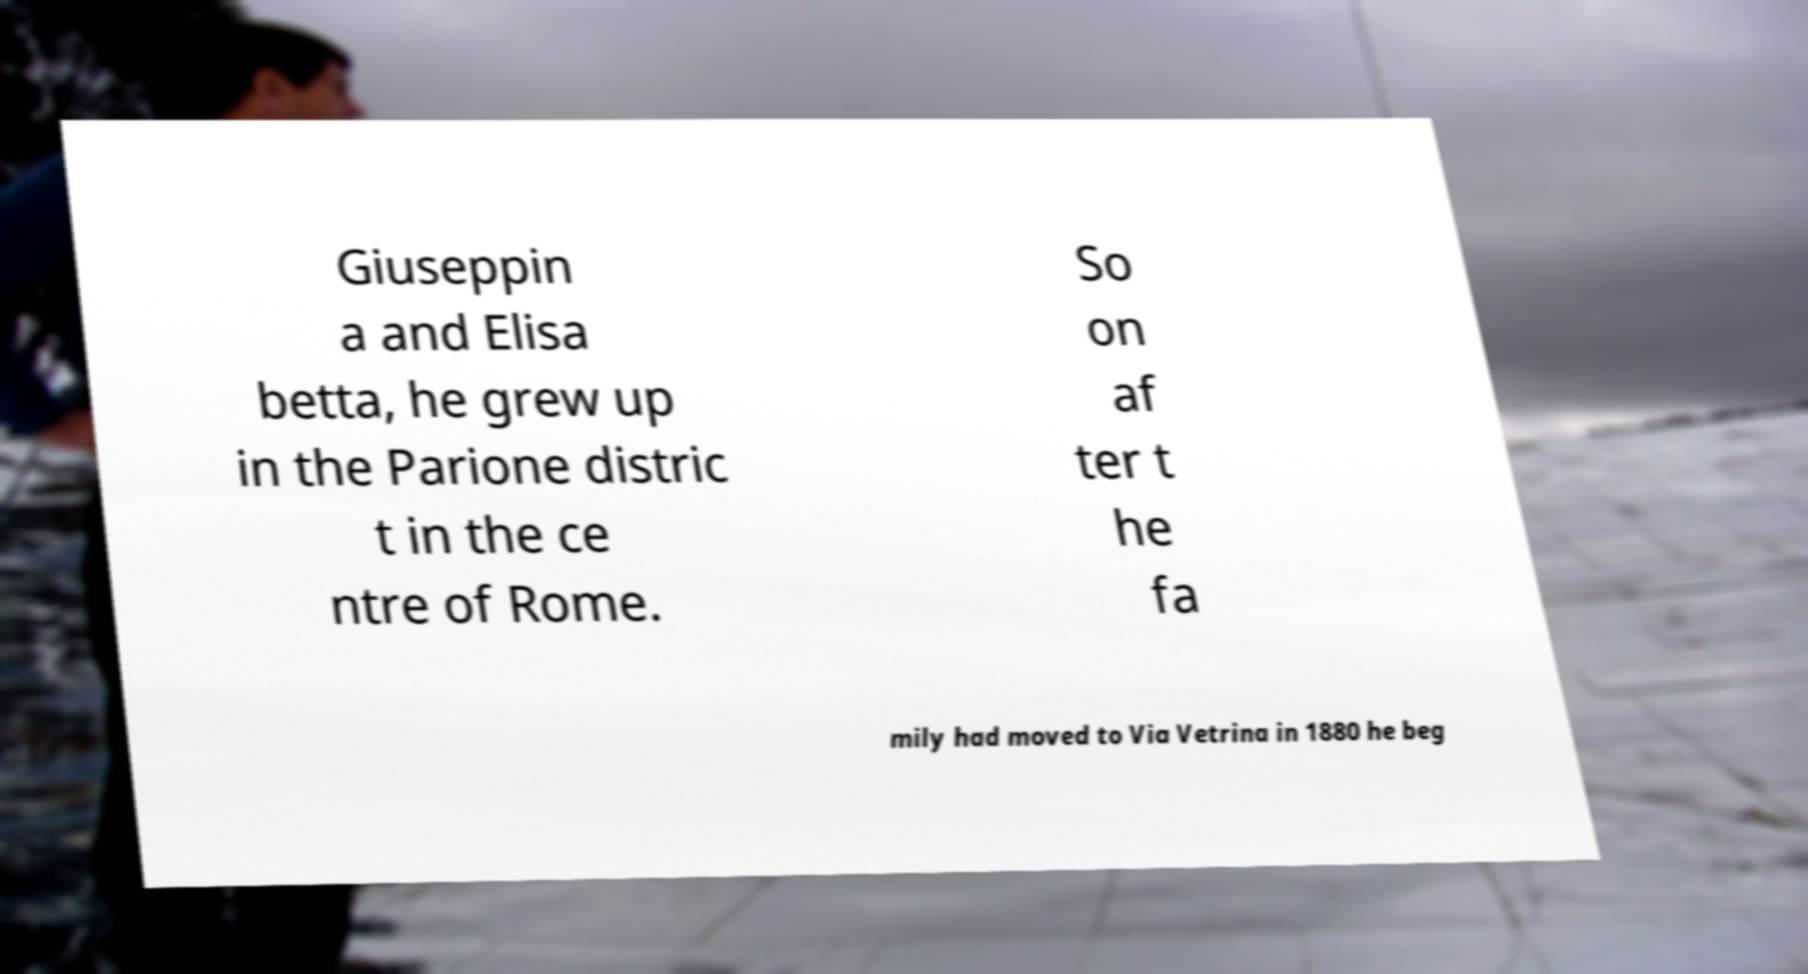What messages or text are displayed in this image? I need them in a readable, typed format. Giuseppin a and Elisa betta, he grew up in the Parione distric t in the ce ntre of Rome. So on af ter t he fa mily had moved to Via Vetrina in 1880 he beg 